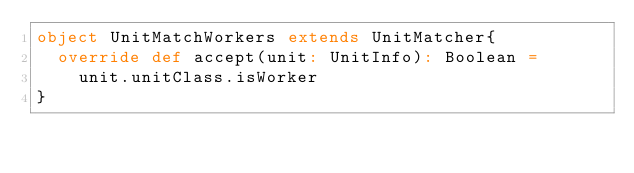<code> <loc_0><loc_0><loc_500><loc_500><_Scala_>object UnitMatchWorkers extends UnitMatcher{
  override def accept(unit: UnitInfo): Boolean =
    unit.unitClass.isWorker
}
</code> 